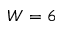Convert formula to latex. <formula><loc_0><loc_0><loc_500><loc_500>W = 6</formula> 